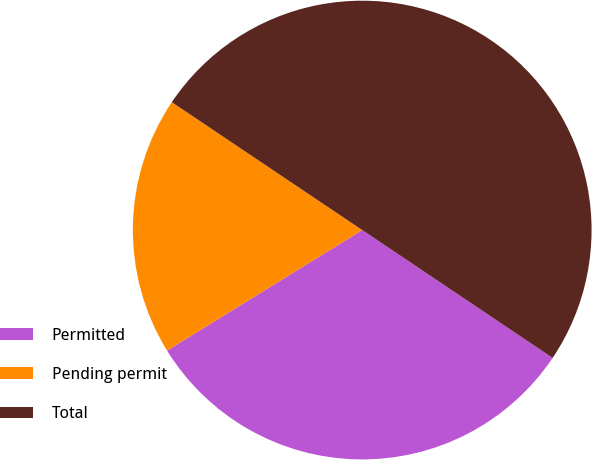Convert chart to OTSL. <chart><loc_0><loc_0><loc_500><loc_500><pie_chart><fcel>Permitted<fcel>Pending permit<fcel>Total<nl><fcel>31.78%<fcel>18.22%<fcel>50.0%<nl></chart> 